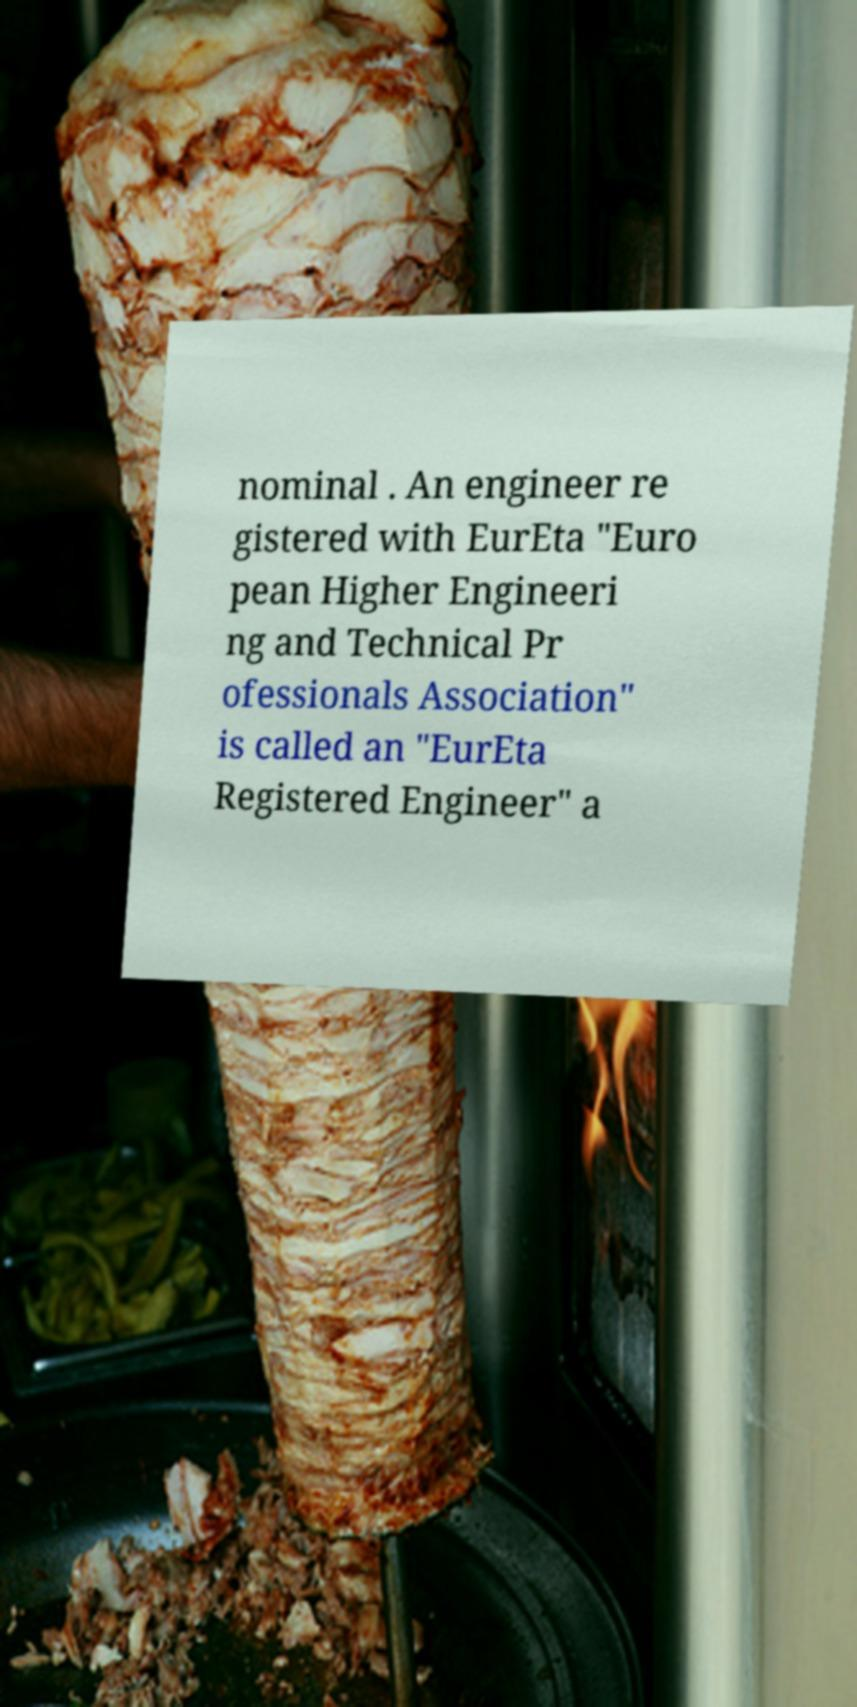There's text embedded in this image that I need extracted. Can you transcribe it verbatim? nominal . An engineer re gistered with EurEta "Euro pean Higher Engineeri ng and Technical Pr ofessionals Association" is called an "EurEta Registered Engineer" a 